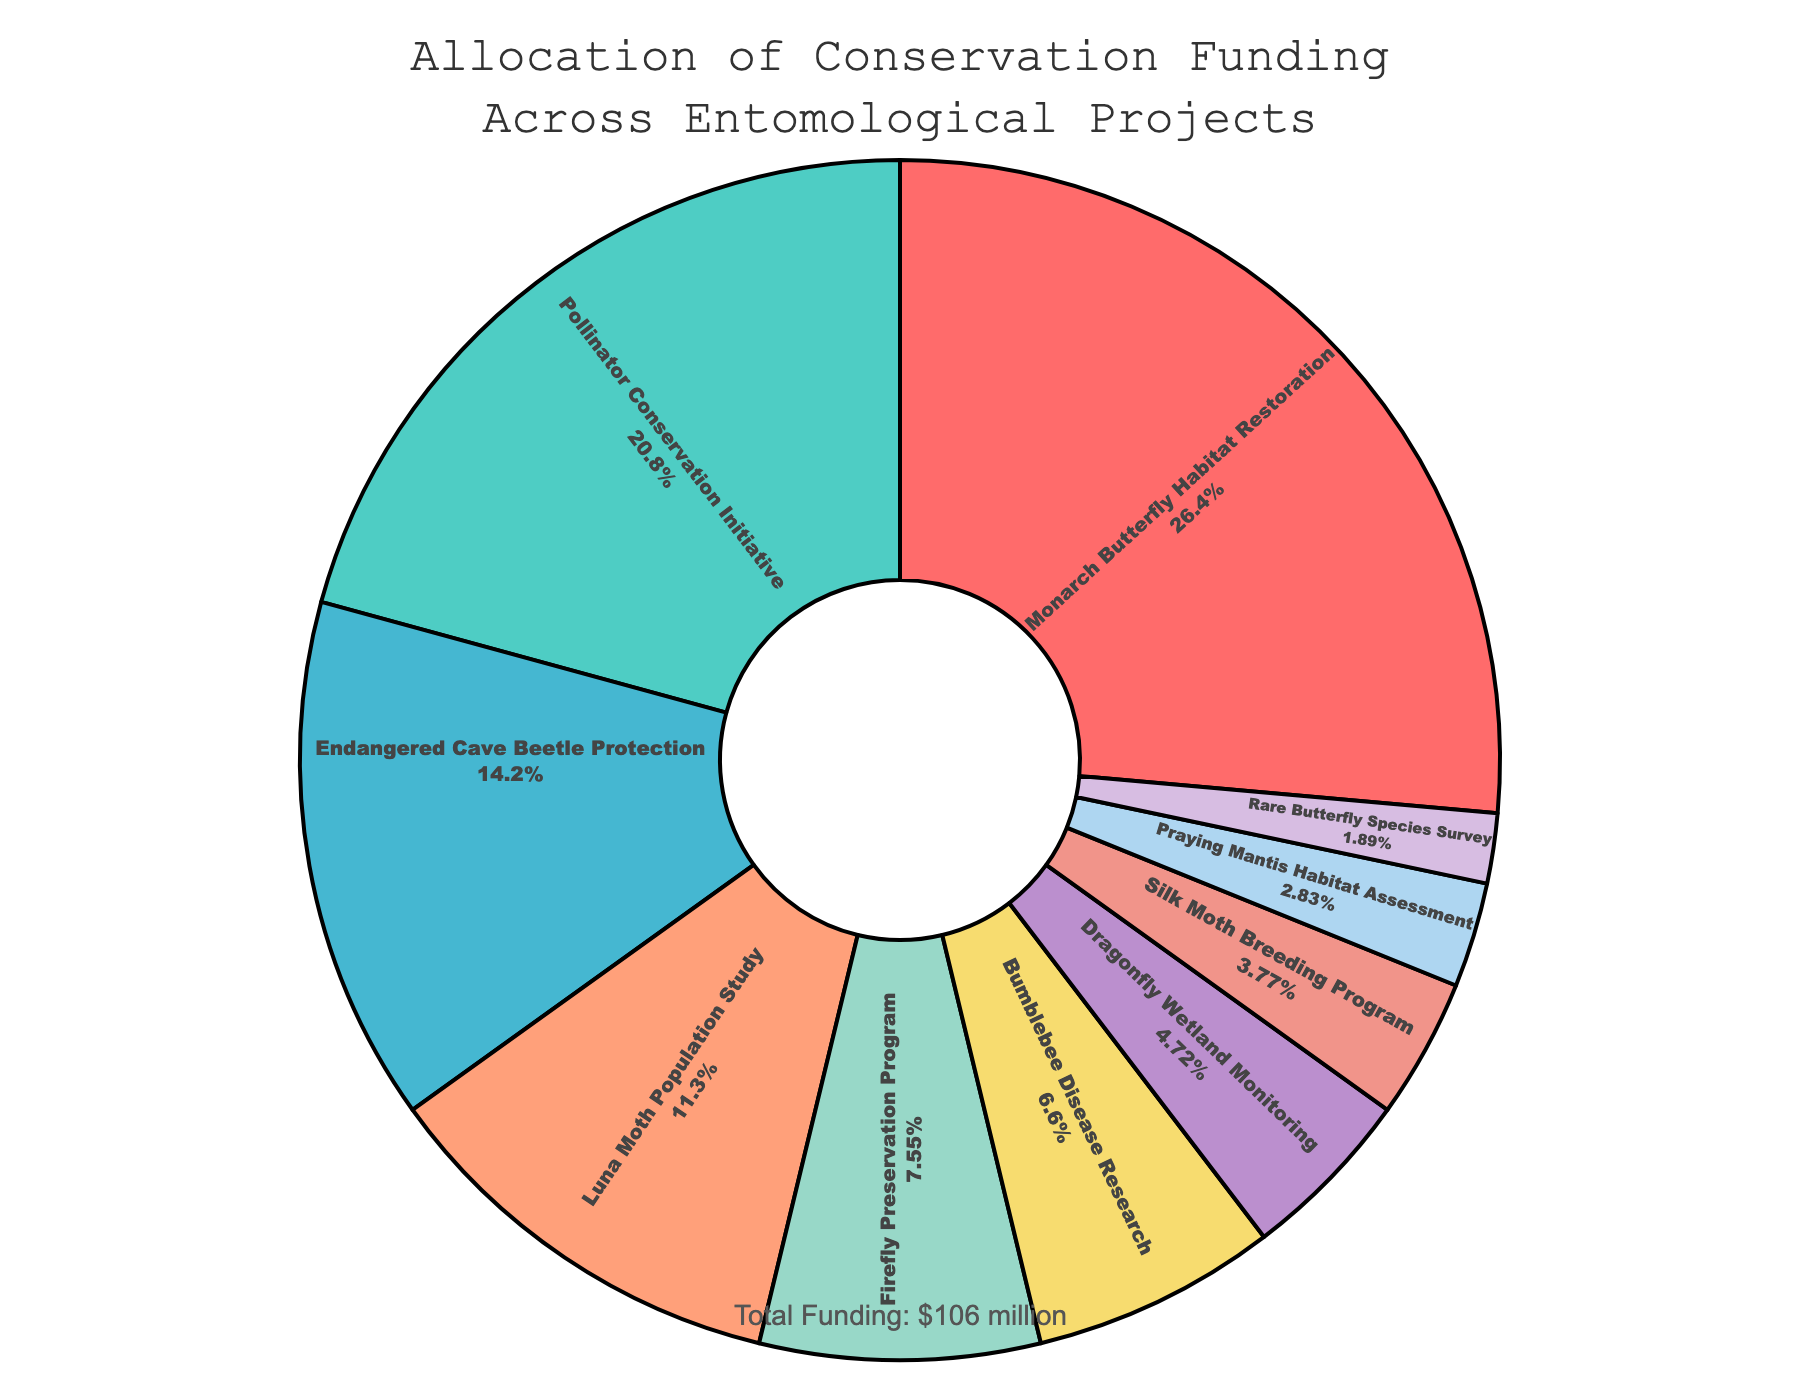Which project receives the highest funding allocation? The pie chart shows that the Monarch Butterfly Habitat Restoration segment is the largest. This indicates that the Monarch Butterfly Habitat Restoration project receives the highest funding allocation.
Answer: Monarch Butterfly Habitat Restoration Which project receives the lowest funding allocation? The pie chart shows the smallest segment is labeled as Rare Butterfly Species Survey. This indicates that the Rare Butterfly Species Survey project receives the lowest funding allocation.
Answer: Rare Butterfly Species Survey How much funding is allocated to the Pollinator Conservation Initiative? The pie chart indicates the allocation percentages along with the project labels. The Pollinator Conservation Initiative has 22% of the total funds. Given the total funding is $106 million, 22% of 106 million is 22/100 * 106 = $23.32 million.
Answer: $23.32 million What is the combined funding allocation for projects related to habitat assessment and habitat restoration (Monarch Butterfly Habitat Restoration and Praying Mantis Habitat Assessment)? The pie chart shows that the Monarch Butterfly Habitat Restoration has an allocation of 28% and the Praying Mantis Habitat Assessment has 3%. Adding these together, 28% + 3% = 31% of the total funding. Given the total funding is $106 million, 31% of 106 million is 31/100 * 106 = $32.86 million.
Answer: $32.86 million Which two projects receive nearly the same amount of funding, and what are their individual allocations? Comparing the sizes of the segments in the pie chart, we see that the Firefly Preservation Program (8%) and Bumblebee Disease Research (7%) appear to be nearly the same size. Thus, their allocations must be $8.48 million and $7.42 million respectively ($106 million * 8/100 = $8.48 million; $106 million * 7/100 = $7.42 million).
Answer: Firefly Preservation Program ($8.48 million), Bumblebee Disease Research ($7.42 million) 